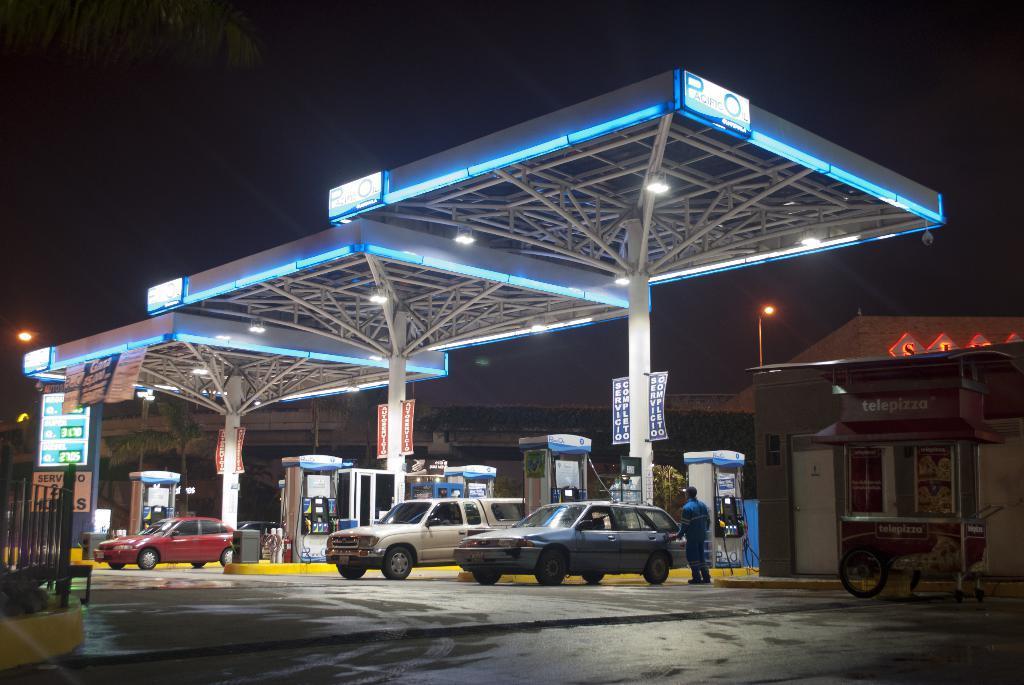How would you summarize this image in a sentence or two? This image is clicked outside. This looks like a petrol bunk. There are lights in the middle. There are cars at the bottom. There is a person in the middle. There is sky at the top. 